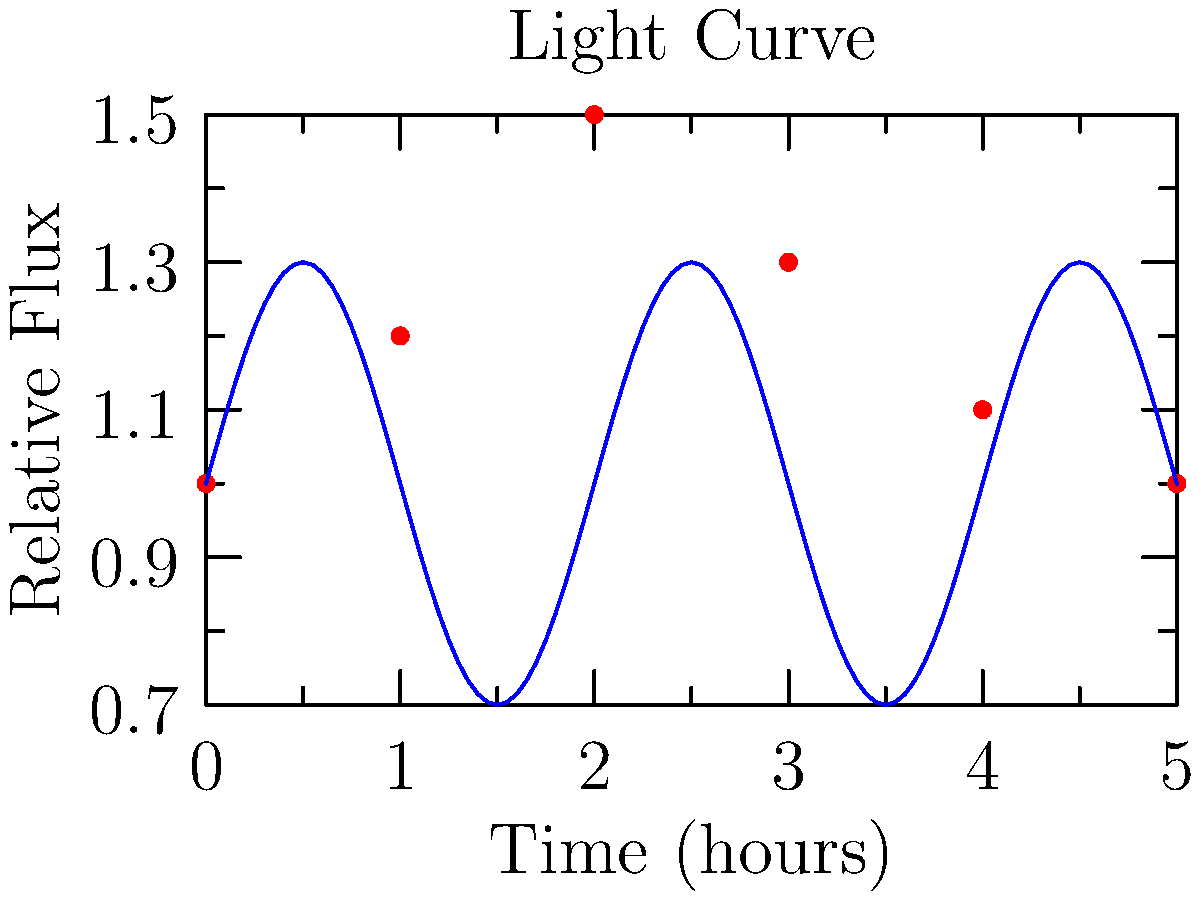Given the light curve data shown in the graph, which regression model would be most suitable for estimating the mass of an exoplanet, and why? To estimate the mass of an exoplanet from light curve data, we need to consider the following steps:

1. Analyze the light curve: The graph shows a periodic variation in the relative flux over time, which is characteristic of an exoplanet transit.

2. Identify the model requirements:
   a) The model should capture periodic behavior.
   b) It should account for the sinusoidal-like shape of the curve.
   c) The model should be able to handle non-linear relationships.

3. Consider regression model options:
   a) Linear regression: Not suitable due to the non-linear nature of the data.
   b) Polynomial regression: Could fit the curve but may overfit with higher degrees.
   c) Sinusoidal regression: Matches the periodic nature of the data.
   d) Non-linear least squares: Can be adapted to fit various non-linear functions.

4. Select the most appropriate model: Sinusoidal regression or non-linear least squares with a sinusoidal function would be most suitable because:
   a) They can capture the periodic nature of the transit.
   b) They match the shape of the observed light curve.
   c) They can provide parameters related to the planet's orbital characteristics.

5. Relate to mass estimation: The amplitude and period of the fitted curve can be used to estimate the planet's radius and orbital period, which, combined with other data (e.g., radial velocity measurements), can lead to mass estimation using Kepler's laws of planetary motion.

The sinusoidal regression model can be expressed as:

$$F(t) = A \sin(2\pi ft + \phi) + C$$

Where $F(t)$ is the relative flux, $A$ is the amplitude, $f$ is the frequency, $t$ is time, $\phi$ is the phase shift, and $C$ is the mean flux level.

By fitting this model to the data, we can extract parameters that are crucial for estimating the exoplanet's properties, including its mass.
Answer: Sinusoidal regression 